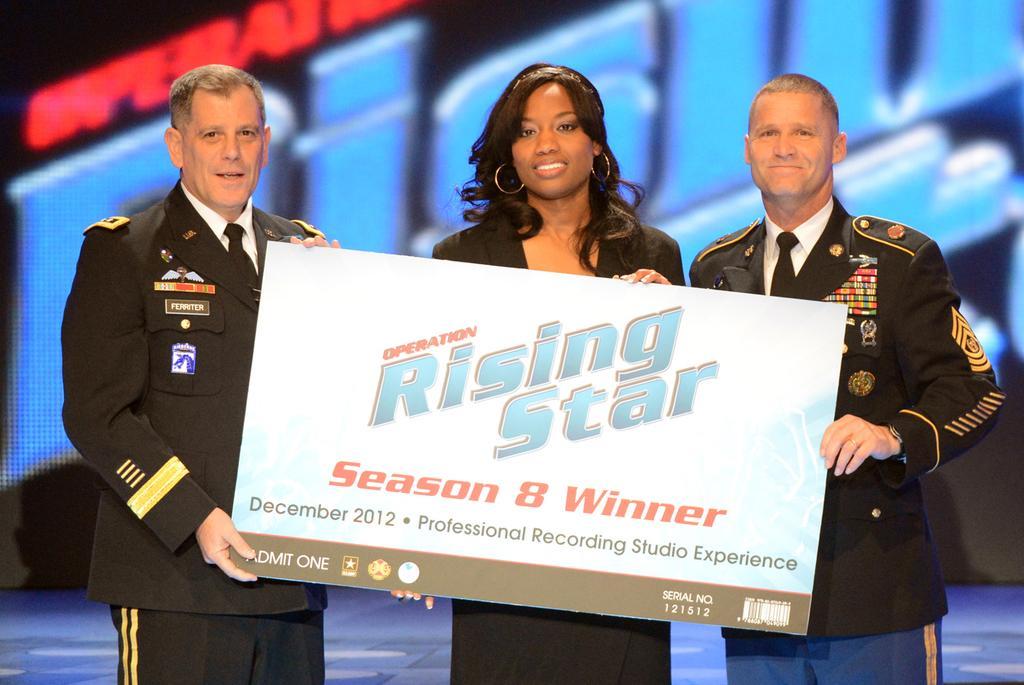How would you summarize this image in a sentence or two? In this image there are two men and a woman standing, they are holding a board, there is text on the board, there are numbers on the board, there is text behind the persons, the background of the image is dark. 